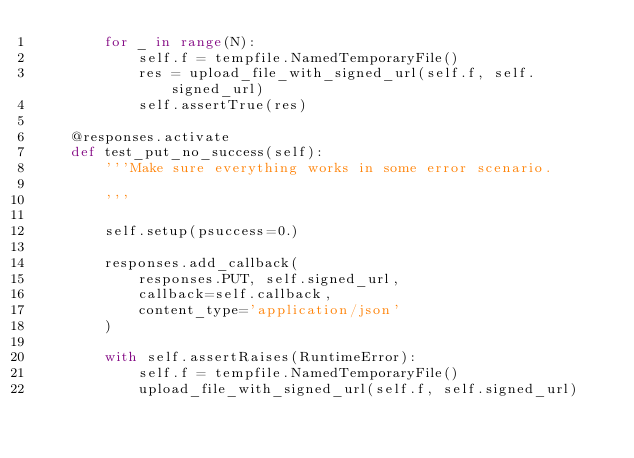Convert code to text. <code><loc_0><loc_0><loc_500><loc_500><_Python_>        for _ in range(N):
            self.f = tempfile.NamedTemporaryFile()
            res = upload_file_with_signed_url(self.f, self.signed_url)
            self.assertTrue(res)

    @responses.activate
    def test_put_no_success(self):
        '''Make sure everything works in some error scenario.

        '''

        self.setup(psuccess=0.)

        responses.add_callback(
            responses.PUT, self.signed_url,
            callback=self.callback,
            content_type='application/json'
        )

        with self.assertRaises(RuntimeError):
            self.f = tempfile.NamedTemporaryFile()
            upload_file_with_signed_url(self.f, self.signed_url)

</code> 